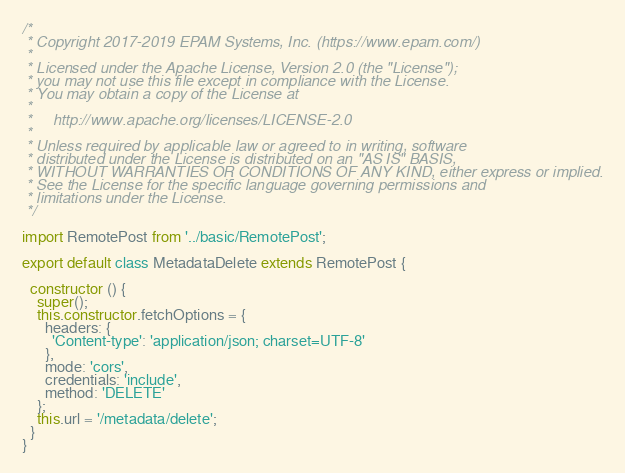Convert code to text. <code><loc_0><loc_0><loc_500><loc_500><_JavaScript_>/*
 * Copyright 2017-2019 EPAM Systems, Inc. (https://www.epam.com/)
 *
 * Licensed under the Apache License, Version 2.0 (the "License");
 * you may not use this file except in compliance with the License.
 * You may obtain a copy of the License at
 *
 *     http://www.apache.org/licenses/LICENSE-2.0
 *
 * Unless required by applicable law or agreed to in writing, software
 * distributed under the License is distributed on an "AS IS" BASIS,
 * WITHOUT WARRANTIES OR CONDITIONS OF ANY KIND, either express or implied.
 * See the License for the specific language governing permissions and
 * limitations under the License.
 */

import RemotePost from '../basic/RemotePost';

export default class MetadataDelete extends RemotePost {

  constructor () {
    super();
    this.constructor.fetchOptions = {
      headers: {
        'Content-type': 'application/json; charset=UTF-8'
      },
      mode: 'cors',
      credentials: 'include',
      method: 'DELETE'
    };
    this.url = '/metadata/delete';
  }
}
</code> 